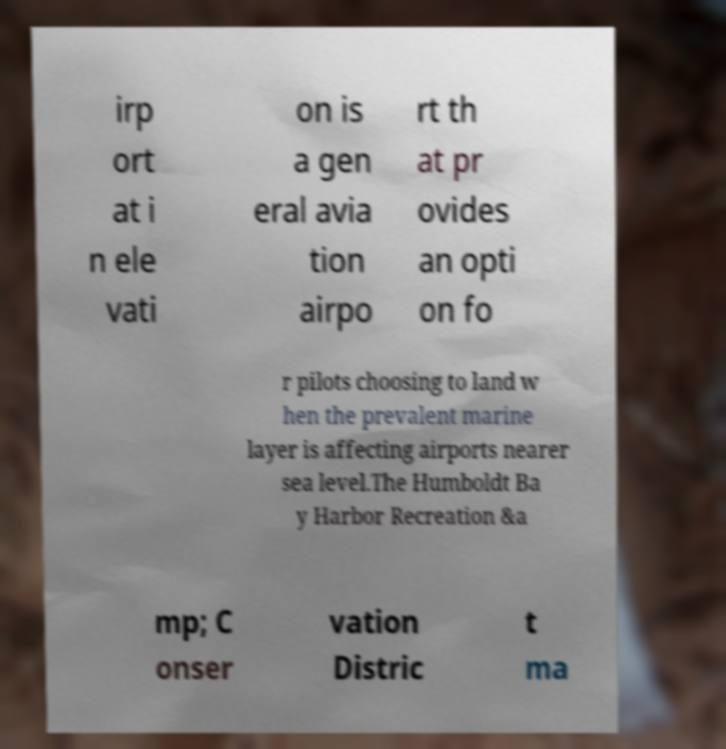Can you read and provide the text displayed in the image?This photo seems to have some interesting text. Can you extract and type it out for me? irp ort at i n ele vati on is a gen eral avia tion airpo rt th at pr ovides an opti on fo r pilots choosing to land w hen the prevalent marine layer is affecting airports nearer sea level.The Humboldt Ba y Harbor Recreation &a mp; C onser vation Distric t ma 